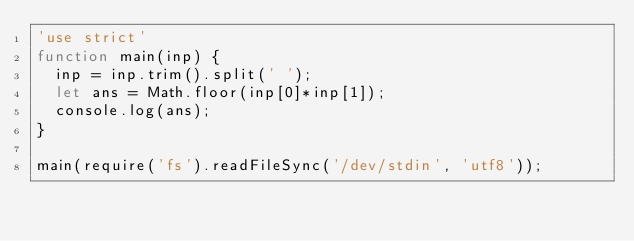<code> <loc_0><loc_0><loc_500><loc_500><_JavaScript_>'use strict'
function main(inp) {
  inp = inp.trim().split(' ');
  let ans = Math.floor(inp[0]*inp[1]);
  console.log(ans); 
}

main(require('fs').readFileSync('/dev/stdin', 'utf8'));
</code> 